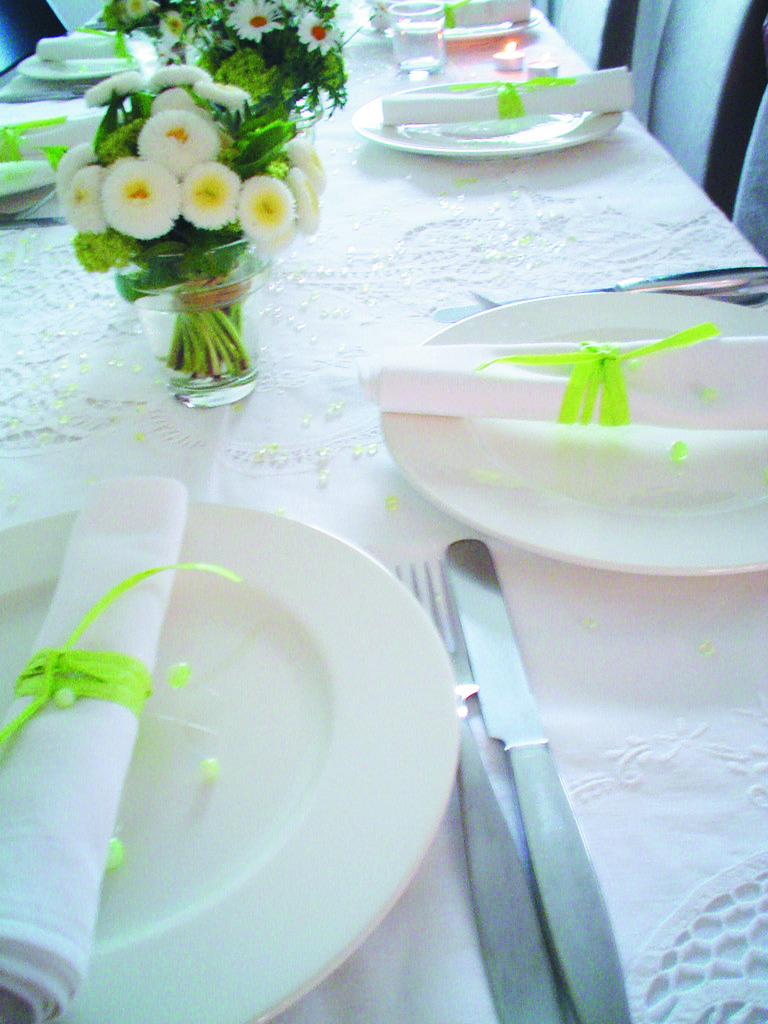What type of furniture is present in the image? There is a dining table in the image. How is the dining table decorated? The dining table is covered with a white cloth. What utensils can be seen on the table? There are knives on the table. What else is present on the table besides utensils? There are plates and a plant on the table. What is an unusual item placed on the plates? Clothes are placed in the plates. What type of bird is sitting on the plant in the image? There is no bird present on the plant in the image. What type of punishment is being served on the plates in the image? There is no punishment present on the plates in the image; only clothes are placed there. 